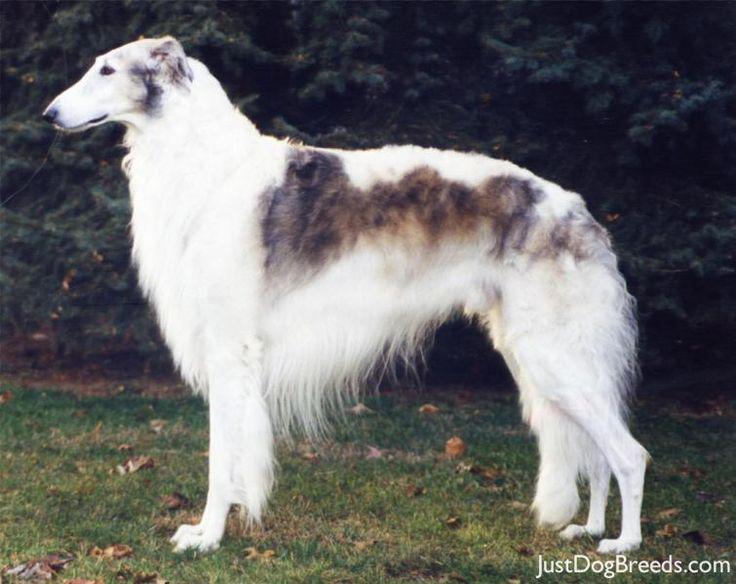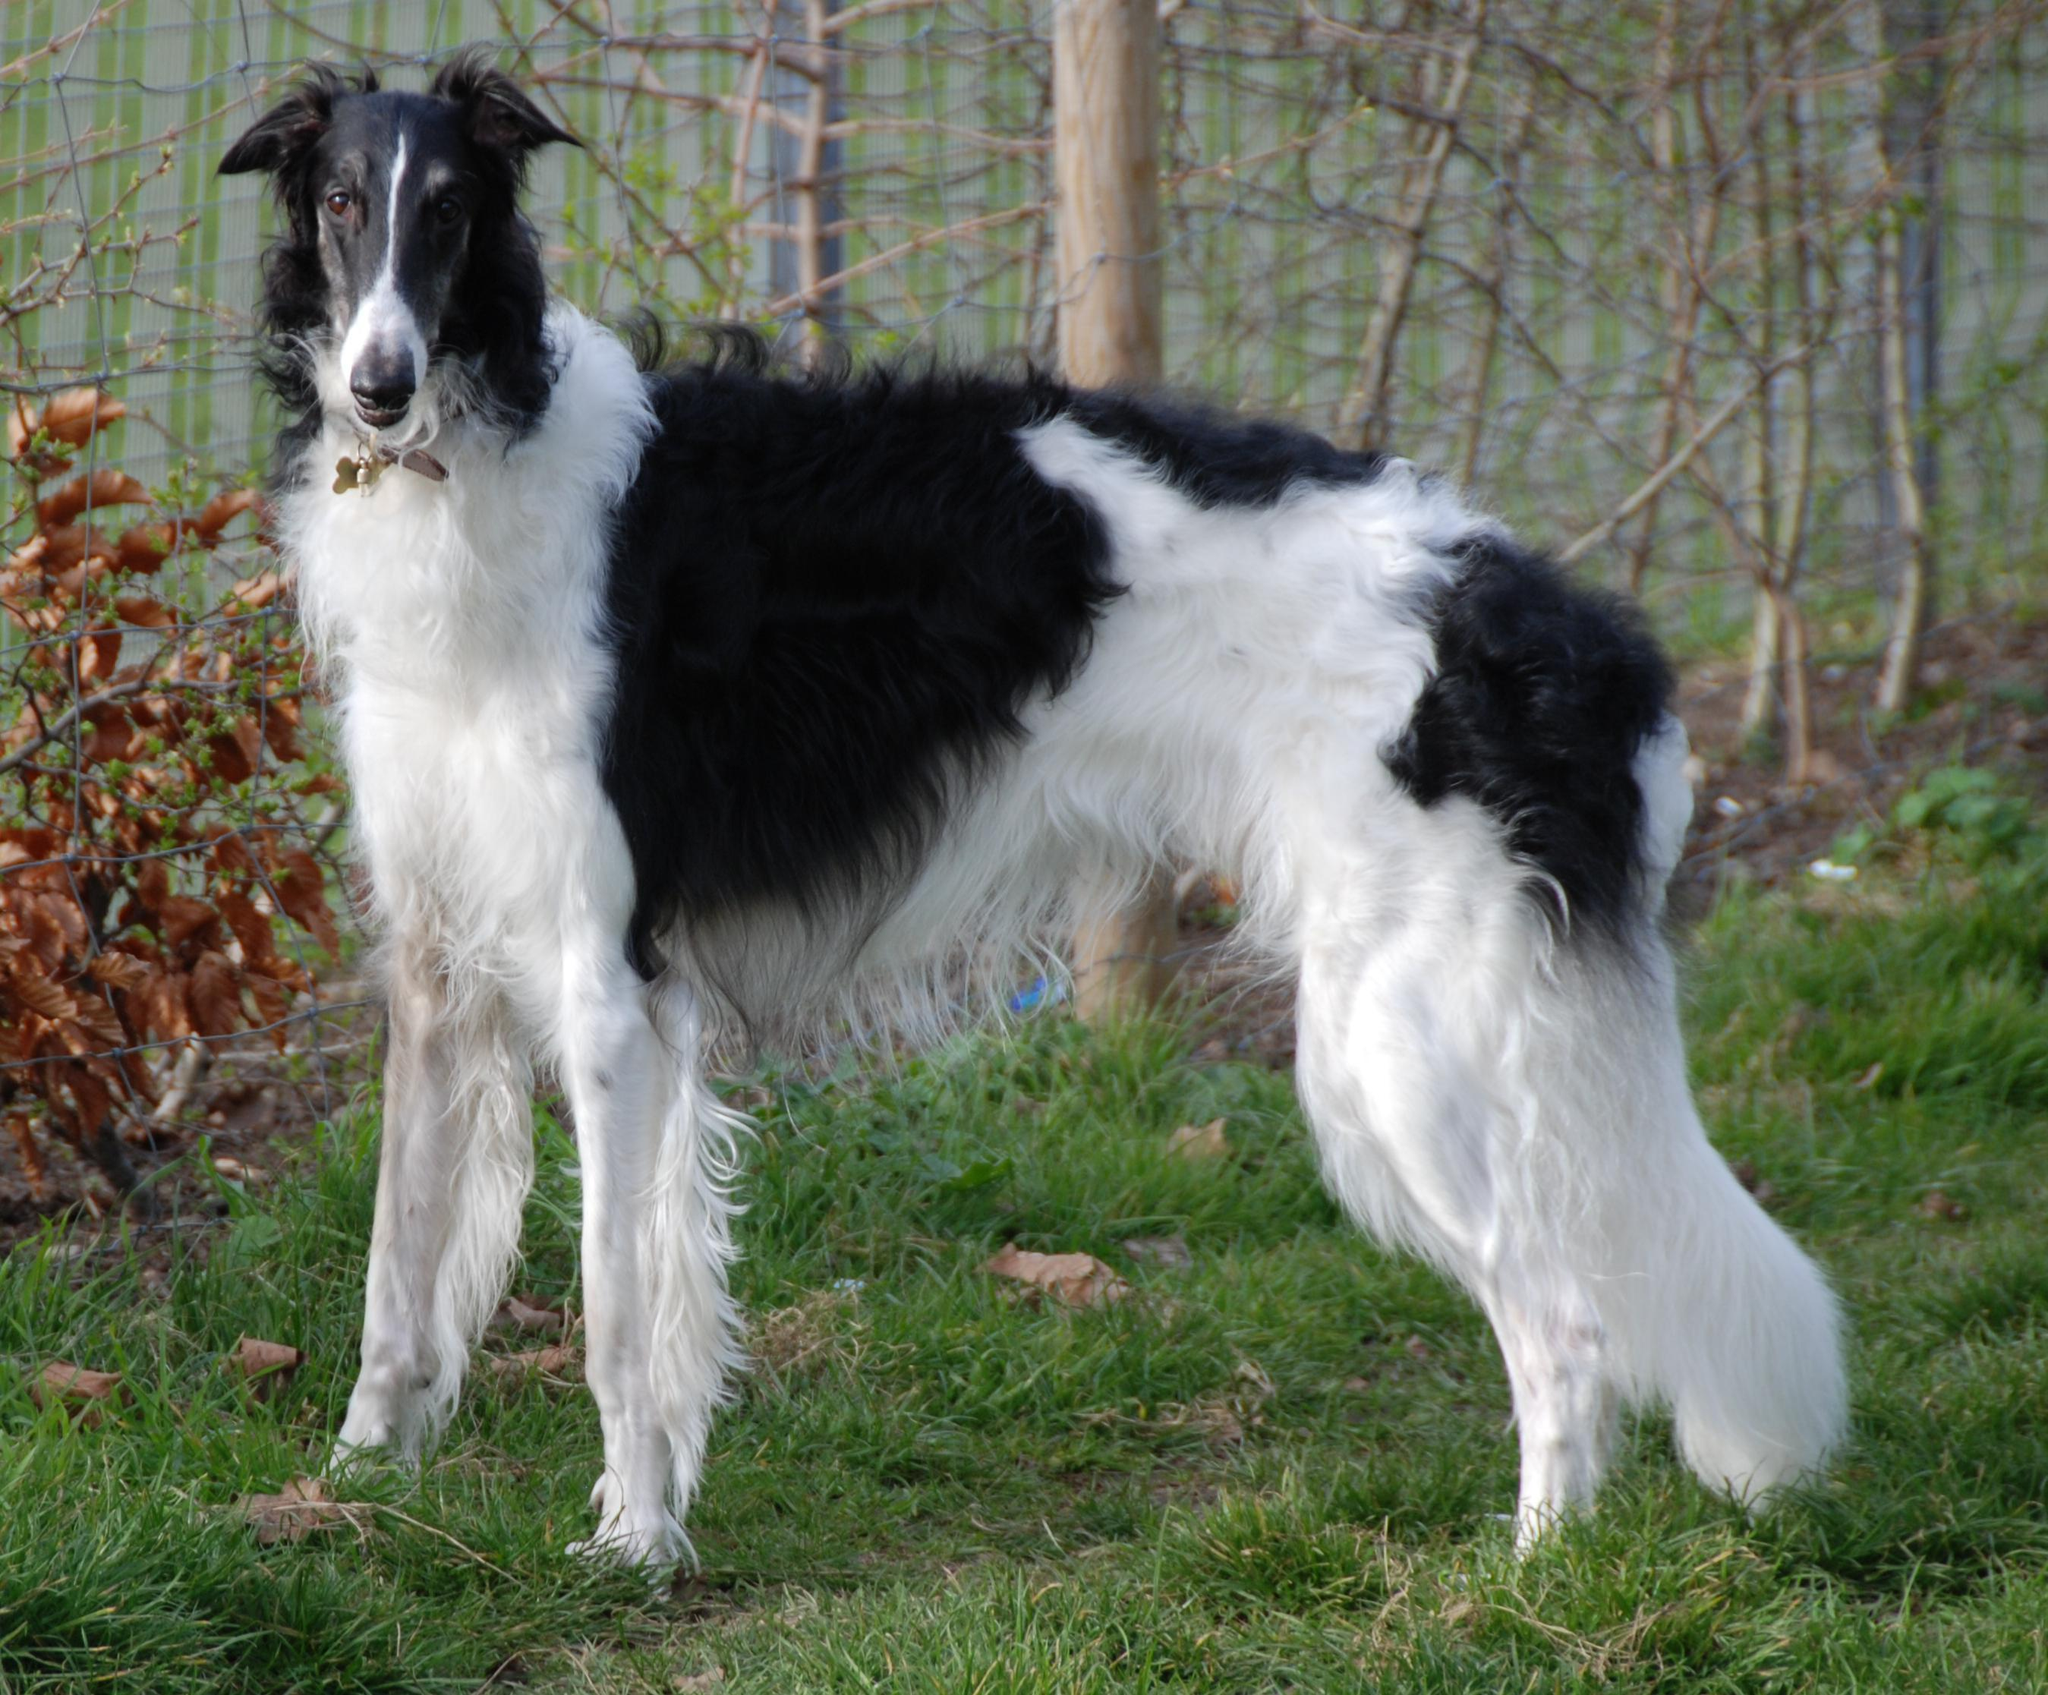The first image is the image on the left, the second image is the image on the right. Evaluate the accuracy of this statement regarding the images: "Right image shows exactly one black and white hound in profile.". Is it true? Answer yes or no. Yes. 